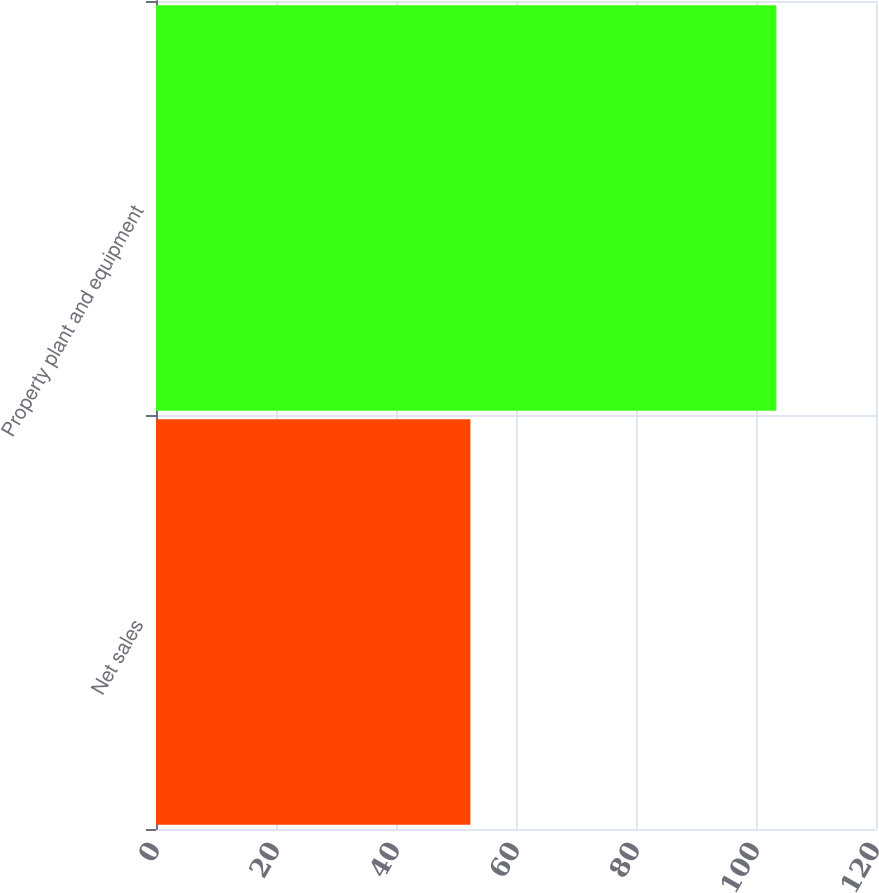<chart> <loc_0><loc_0><loc_500><loc_500><bar_chart><fcel>Net sales<fcel>Property plant and equipment<nl><fcel>52.4<fcel>103.4<nl></chart> 